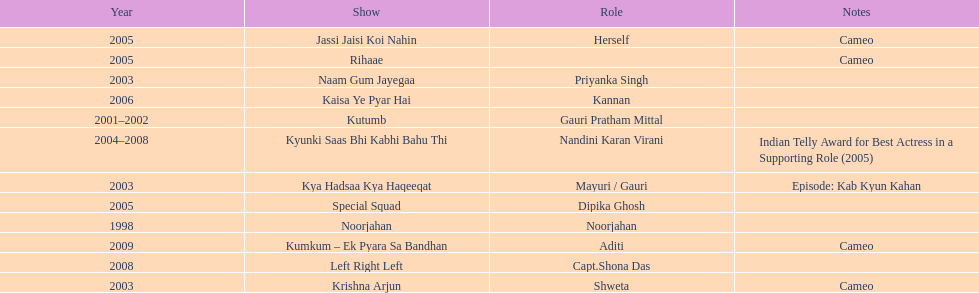How many shows were there in 2005? 3. 